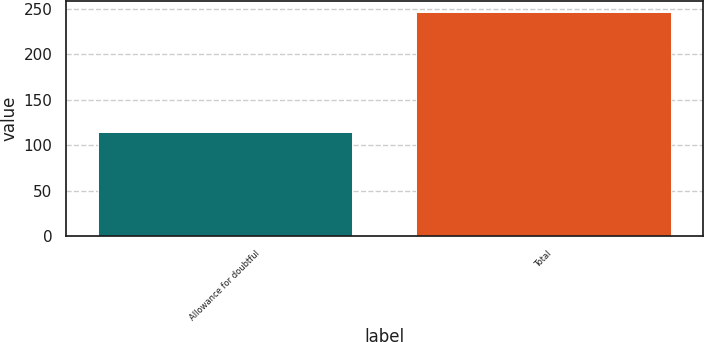Convert chart to OTSL. <chart><loc_0><loc_0><loc_500><loc_500><bar_chart><fcel>Allowance for doubtful<fcel>Total<nl><fcel>114.7<fcel>246.3<nl></chart> 